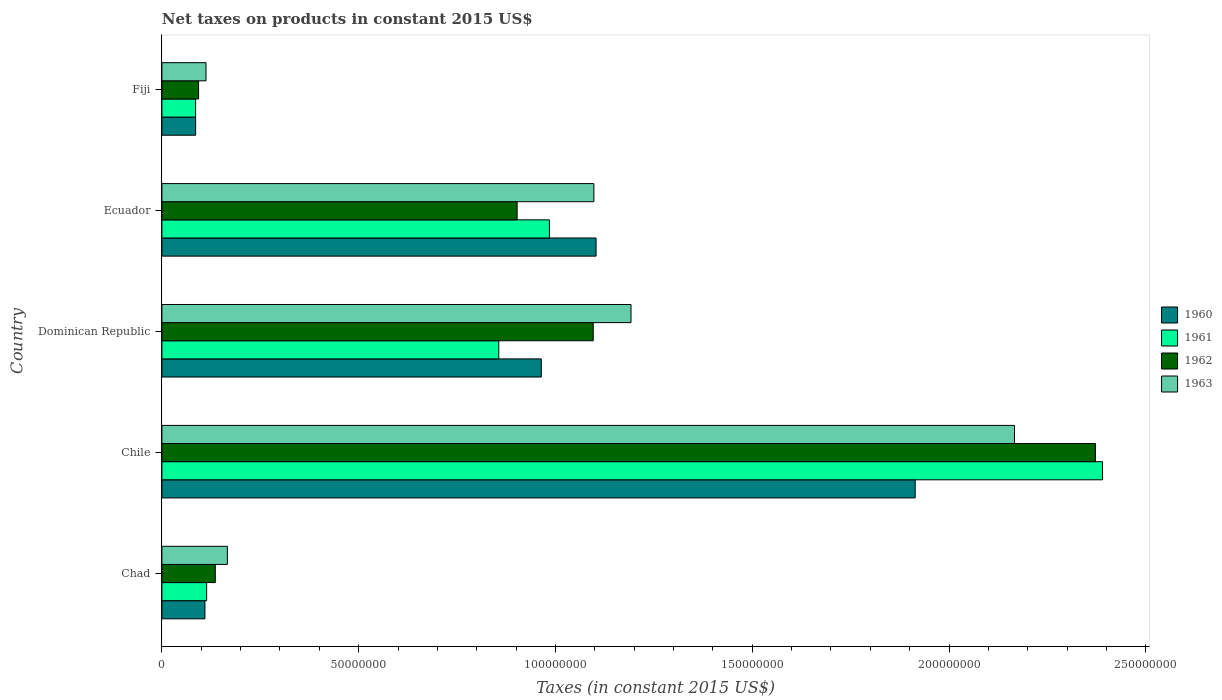Are the number of bars per tick equal to the number of legend labels?
Offer a terse response. Yes. Are the number of bars on each tick of the Y-axis equal?
Offer a very short reply. Yes. What is the label of the 2nd group of bars from the top?
Offer a very short reply. Ecuador. What is the net taxes on products in 1962 in Dominican Republic?
Make the answer very short. 1.10e+08. Across all countries, what is the maximum net taxes on products in 1963?
Offer a very short reply. 2.17e+08. Across all countries, what is the minimum net taxes on products in 1962?
Your answer should be very brief. 9.32e+06. In which country was the net taxes on products in 1960 minimum?
Ensure brevity in your answer.  Fiji. What is the total net taxes on products in 1962 in the graph?
Provide a succinct answer. 4.60e+08. What is the difference between the net taxes on products in 1962 in Chile and that in Fiji?
Make the answer very short. 2.28e+08. What is the difference between the net taxes on products in 1963 in Chile and the net taxes on products in 1960 in Fiji?
Provide a short and direct response. 2.08e+08. What is the average net taxes on products in 1960 per country?
Ensure brevity in your answer.  8.35e+07. What is the difference between the net taxes on products in 1962 and net taxes on products in 1960 in Chad?
Offer a very short reply. 2.63e+06. In how many countries, is the net taxes on products in 1963 greater than 150000000 US$?
Make the answer very short. 1. What is the ratio of the net taxes on products in 1960 in Chad to that in Chile?
Offer a terse response. 0.06. Is the net taxes on products in 1961 in Chile less than that in Fiji?
Provide a short and direct response. No. Is the difference between the net taxes on products in 1962 in Chad and Chile greater than the difference between the net taxes on products in 1960 in Chad and Chile?
Keep it short and to the point. No. What is the difference between the highest and the second highest net taxes on products in 1962?
Your response must be concise. 1.28e+08. What is the difference between the highest and the lowest net taxes on products in 1961?
Your answer should be compact. 2.30e+08. In how many countries, is the net taxes on products in 1961 greater than the average net taxes on products in 1961 taken over all countries?
Your answer should be compact. 2. What does the 4th bar from the top in Fiji represents?
Ensure brevity in your answer.  1960. What does the 4th bar from the bottom in Dominican Republic represents?
Your answer should be compact. 1963. Is it the case that in every country, the sum of the net taxes on products in 1962 and net taxes on products in 1963 is greater than the net taxes on products in 1961?
Give a very brief answer. Yes. How many bars are there?
Your answer should be very brief. 20. How many countries are there in the graph?
Your answer should be compact. 5. What is the difference between two consecutive major ticks on the X-axis?
Provide a succinct answer. 5.00e+07. Are the values on the major ticks of X-axis written in scientific E-notation?
Make the answer very short. No. Does the graph contain any zero values?
Provide a short and direct response. No. Where does the legend appear in the graph?
Give a very brief answer. Center right. How many legend labels are there?
Your response must be concise. 4. What is the title of the graph?
Keep it short and to the point. Net taxes on products in constant 2015 US$. What is the label or title of the X-axis?
Make the answer very short. Taxes (in constant 2015 US$). What is the label or title of the Y-axis?
Ensure brevity in your answer.  Country. What is the Taxes (in constant 2015 US$) in 1960 in Chad?
Provide a short and direct response. 1.09e+07. What is the Taxes (in constant 2015 US$) of 1961 in Chad?
Offer a terse response. 1.14e+07. What is the Taxes (in constant 2015 US$) of 1962 in Chad?
Make the answer very short. 1.36e+07. What is the Taxes (in constant 2015 US$) in 1963 in Chad?
Your answer should be very brief. 1.66e+07. What is the Taxes (in constant 2015 US$) in 1960 in Chile?
Your response must be concise. 1.91e+08. What is the Taxes (in constant 2015 US$) in 1961 in Chile?
Offer a very short reply. 2.39e+08. What is the Taxes (in constant 2015 US$) in 1962 in Chile?
Provide a short and direct response. 2.37e+08. What is the Taxes (in constant 2015 US$) in 1963 in Chile?
Give a very brief answer. 2.17e+08. What is the Taxes (in constant 2015 US$) in 1960 in Dominican Republic?
Give a very brief answer. 9.64e+07. What is the Taxes (in constant 2015 US$) in 1961 in Dominican Republic?
Your answer should be compact. 8.56e+07. What is the Taxes (in constant 2015 US$) of 1962 in Dominican Republic?
Ensure brevity in your answer.  1.10e+08. What is the Taxes (in constant 2015 US$) in 1963 in Dominican Republic?
Give a very brief answer. 1.19e+08. What is the Taxes (in constant 2015 US$) in 1960 in Ecuador?
Offer a terse response. 1.10e+08. What is the Taxes (in constant 2015 US$) in 1961 in Ecuador?
Make the answer very short. 9.85e+07. What is the Taxes (in constant 2015 US$) in 1962 in Ecuador?
Your answer should be compact. 9.03e+07. What is the Taxes (in constant 2015 US$) in 1963 in Ecuador?
Offer a very short reply. 1.10e+08. What is the Taxes (in constant 2015 US$) in 1960 in Fiji?
Keep it short and to the point. 8.56e+06. What is the Taxes (in constant 2015 US$) in 1961 in Fiji?
Your answer should be very brief. 8.56e+06. What is the Taxes (in constant 2015 US$) in 1962 in Fiji?
Keep it short and to the point. 9.32e+06. What is the Taxes (in constant 2015 US$) of 1963 in Fiji?
Your answer should be very brief. 1.12e+07. Across all countries, what is the maximum Taxes (in constant 2015 US$) of 1960?
Ensure brevity in your answer.  1.91e+08. Across all countries, what is the maximum Taxes (in constant 2015 US$) in 1961?
Offer a very short reply. 2.39e+08. Across all countries, what is the maximum Taxes (in constant 2015 US$) in 1962?
Make the answer very short. 2.37e+08. Across all countries, what is the maximum Taxes (in constant 2015 US$) in 1963?
Ensure brevity in your answer.  2.17e+08. Across all countries, what is the minimum Taxes (in constant 2015 US$) of 1960?
Your response must be concise. 8.56e+06. Across all countries, what is the minimum Taxes (in constant 2015 US$) of 1961?
Your answer should be compact. 8.56e+06. Across all countries, what is the minimum Taxes (in constant 2015 US$) of 1962?
Your answer should be very brief. 9.32e+06. Across all countries, what is the minimum Taxes (in constant 2015 US$) of 1963?
Offer a terse response. 1.12e+07. What is the total Taxes (in constant 2015 US$) in 1960 in the graph?
Offer a terse response. 4.18e+08. What is the total Taxes (in constant 2015 US$) of 1961 in the graph?
Give a very brief answer. 4.43e+08. What is the total Taxes (in constant 2015 US$) of 1962 in the graph?
Your response must be concise. 4.60e+08. What is the total Taxes (in constant 2015 US$) of 1963 in the graph?
Give a very brief answer. 4.73e+08. What is the difference between the Taxes (in constant 2015 US$) in 1960 in Chad and that in Chile?
Provide a succinct answer. -1.80e+08. What is the difference between the Taxes (in constant 2015 US$) in 1961 in Chad and that in Chile?
Provide a short and direct response. -2.28e+08. What is the difference between the Taxes (in constant 2015 US$) of 1962 in Chad and that in Chile?
Your response must be concise. -2.24e+08. What is the difference between the Taxes (in constant 2015 US$) in 1963 in Chad and that in Chile?
Provide a short and direct response. -2.00e+08. What is the difference between the Taxes (in constant 2015 US$) in 1960 in Chad and that in Dominican Republic?
Your answer should be very brief. -8.55e+07. What is the difference between the Taxes (in constant 2015 US$) of 1961 in Chad and that in Dominican Republic?
Offer a terse response. -7.42e+07. What is the difference between the Taxes (in constant 2015 US$) of 1962 in Chad and that in Dominican Republic?
Ensure brevity in your answer.  -9.60e+07. What is the difference between the Taxes (in constant 2015 US$) in 1963 in Chad and that in Dominican Republic?
Give a very brief answer. -1.03e+08. What is the difference between the Taxes (in constant 2015 US$) in 1960 in Chad and that in Ecuador?
Your answer should be compact. -9.94e+07. What is the difference between the Taxes (in constant 2015 US$) of 1961 in Chad and that in Ecuador?
Your answer should be compact. -8.71e+07. What is the difference between the Taxes (in constant 2015 US$) in 1962 in Chad and that in Ecuador?
Ensure brevity in your answer.  -7.67e+07. What is the difference between the Taxes (in constant 2015 US$) of 1963 in Chad and that in Ecuador?
Your answer should be very brief. -9.31e+07. What is the difference between the Taxes (in constant 2015 US$) of 1960 in Chad and that in Fiji?
Offer a very short reply. 2.37e+06. What is the difference between the Taxes (in constant 2015 US$) of 1961 in Chad and that in Fiji?
Your answer should be very brief. 2.81e+06. What is the difference between the Taxes (in constant 2015 US$) in 1962 in Chad and that in Fiji?
Make the answer very short. 4.25e+06. What is the difference between the Taxes (in constant 2015 US$) in 1963 in Chad and that in Fiji?
Provide a short and direct response. 5.43e+06. What is the difference between the Taxes (in constant 2015 US$) in 1960 in Chile and that in Dominican Republic?
Make the answer very short. 9.50e+07. What is the difference between the Taxes (in constant 2015 US$) in 1961 in Chile and that in Dominican Republic?
Provide a short and direct response. 1.53e+08. What is the difference between the Taxes (in constant 2015 US$) of 1962 in Chile and that in Dominican Republic?
Your answer should be compact. 1.28e+08. What is the difference between the Taxes (in constant 2015 US$) of 1963 in Chile and that in Dominican Republic?
Make the answer very short. 9.74e+07. What is the difference between the Taxes (in constant 2015 US$) in 1960 in Chile and that in Ecuador?
Your response must be concise. 8.11e+07. What is the difference between the Taxes (in constant 2015 US$) of 1961 in Chile and that in Ecuador?
Offer a very short reply. 1.41e+08. What is the difference between the Taxes (in constant 2015 US$) of 1962 in Chile and that in Ecuador?
Keep it short and to the point. 1.47e+08. What is the difference between the Taxes (in constant 2015 US$) in 1963 in Chile and that in Ecuador?
Your answer should be very brief. 1.07e+08. What is the difference between the Taxes (in constant 2015 US$) in 1960 in Chile and that in Fiji?
Your response must be concise. 1.83e+08. What is the difference between the Taxes (in constant 2015 US$) of 1961 in Chile and that in Fiji?
Give a very brief answer. 2.30e+08. What is the difference between the Taxes (in constant 2015 US$) in 1962 in Chile and that in Fiji?
Make the answer very short. 2.28e+08. What is the difference between the Taxes (in constant 2015 US$) of 1963 in Chile and that in Fiji?
Ensure brevity in your answer.  2.05e+08. What is the difference between the Taxes (in constant 2015 US$) in 1960 in Dominican Republic and that in Ecuador?
Provide a succinct answer. -1.39e+07. What is the difference between the Taxes (in constant 2015 US$) of 1961 in Dominican Republic and that in Ecuador?
Your response must be concise. -1.29e+07. What is the difference between the Taxes (in constant 2015 US$) of 1962 in Dominican Republic and that in Ecuador?
Offer a very short reply. 1.93e+07. What is the difference between the Taxes (in constant 2015 US$) of 1963 in Dominican Republic and that in Ecuador?
Keep it short and to the point. 9.44e+06. What is the difference between the Taxes (in constant 2015 US$) of 1960 in Dominican Republic and that in Fiji?
Ensure brevity in your answer.  8.78e+07. What is the difference between the Taxes (in constant 2015 US$) in 1961 in Dominican Republic and that in Fiji?
Your answer should be compact. 7.70e+07. What is the difference between the Taxes (in constant 2015 US$) in 1962 in Dominican Republic and that in Fiji?
Your answer should be compact. 1.00e+08. What is the difference between the Taxes (in constant 2015 US$) in 1963 in Dominican Republic and that in Fiji?
Your response must be concise. 1.08e+08. What is the difference between the Taxes (in constant 2015 US$) of 1960 in Ecuador and that in Fiji?
Offer a very short reply. 1.02e+08. What is the difference between the Taxes (in constant 2015 US$) in 1961 in Ecuador and that in Fiji?
Provide a short and direct response. 8.99e+07. What is the difference between the Taxes (in constant 2015 US$) in 1962 in Ecuador and that in Fiji?
Give a very brief answer. 8.09e+07. What is the difference between the Taxes (in constant 2015 US$) in 1963 in Ecuador and that in Fiji?
Provide a short and direct response. 9.86e+07. What is the difference between the Taxes (in constant 2015 US$) of 1960 in Chad and the Taxes (in constant 2015 US$) of 1961 in Chile?
Keep it short and to the point. -2.28e+08. What is the difference between the Taxes (in constant 2015 US$) of 1960 in Chad and the Taxes (in constant 2015 US$) of 1962 in Chile?
Provide a succinct answer. -2.26e+08. What is the difference between the Taxes (in constant 2015 US$) of 1960 in Chad and the Taxes (in constant 2015 US$) of 1963 in Chile?
Your answer should be very brief. -2.06e+08. What is the difference between the Taxes (in constant 2015 US$) of 1961 in Chad and the Taxes (in constant 2015 US$) of 1962 in Chile?
Keep it short and to the point. -2.26e+08. What is the difference between the Taxes (in constant 2015 US$) in 1961 in Chad and the Taxes (in constant 2015 US$) in 1963 in Chile?
Provide a succinct answer. -2.05e+08. What is the difference between the Taxes (in constant 2015 US$) of 1962 in Chad and the Taxes (in constant 2015 US$) of 1963 in Chile?
Provide a succinct answer. -2.03e+08. What is the difference between the Taxes (in constant 2015 US$) of 1960 in Chad and the Taxes (in constant 2015 US$) of 1961 in Dominican Republic?
Ensure brevity in your answer.  -7.47e+07. What is the difference between the Taxes (in constant 2015 US$) of 1960 in Chad and the Taxes (in constant 2015 US$) of 1962 in Dominican Republic?
Offer a terse response. -9.87e+07. What is the difference between the Taxes (in constant 2015 US$) of 1960 in Chad and the Taxes (in constant 2015 US$) of 1963 in Dominican Republic?
Make the answer very short. -1.08e+08. What is the difference between the Taxes (in constant 2015 US$) in 1961 in Chad and the Taxes (in constant 2015 US$) in 1962 in Dominican Republic?
Your answer should be compact. -9.82e+07. What is the difference between the Taxes (in constant 2015 US$) in 1961 in Chad and the Taxes (in constant 2015 US$) in 1963 in Dominican Republic?
Your answer should be compact. -1.08e+08. What is the difference between the Taxes (in constant 2015 US$) in 1962 in Chad and the Taxes (in constant 2015 US$) in 1963 in Dominican Republic?
Offer a terse response. -1.06e+08. What is the difference between the Taxes (in constant 2015 US$) in 1960 in Chad and the Taxes (in constant 2015 US$) in 1961 in Ecuador?
Provide a succinct answer. -8.75e+07. What is the difference between the Taxes (in constant 2015 US$) in 1960 in Chad and the Taxes (in constant 2015 US$) in 1962 in Ecuador?
Ensure brevity in your answer.  -7.93e+07. What is the difference between the Taxes (in constant 2015 US$) in 1960 in Chad and the Taxes (in constant 2015 US$) in 1963 in Ecuador?
Make the answer very short. -9.88e+07. What is the difference between the Taxes (in constant 2015 US$) in 1961 in Chad and the Taxes (in constant 2015 US$) in 1962 in Ecuador?
Offer a very short reply. -7.89e+07. What is the difference between the Taxes (in constant 2015 US$) in 1961 in Chad and the Taxes (in constant 2015 US$) in 1963 in Ecuador?
Offer a terse response. -9.84e+07. What is the difference between the Taxes (in constant 2015 US$) of 1962 in Chad and the Taxes (in constant 2015 US$) of 1963 in Ecuador?
Provide a short and direct response. -9.62e+07. What is the difference between the Taxes (in constant 2015 US$) in 1960 in Chad and the Taxes (in constant 2015 US$) in 1961 in Fiji?
Offer a very short reply. 2.37e+06. What is the difference between the Taxes (in constant 2015 US$) in 1960 in Chad and the Taxes (in constant 2015 US$) in 1962 in Fiji?
Keep it short and to the point. 1.62e+06. What is the difference between the Taxes (in constant 2015 US$) in 1960 in Chad and the Taxes (in constant 2015 US$) in 1963 in Fiji?
Offer a terse response. -2.73e+05. What is the difference between the Taxes (in constant 2015 US$) in 1961 in Chad and the Taxes (in constant 2015 US$) in 1962 in Fiji?
Your answer should be compact. 2.05e+06. What is the difference between the Taxes (in constant 2015 US$) of 1961 in Chad and the Taxes (in constant 2015 US$) of 1963 in Fiji?
Make the answer very short. 1.61e+05. What is the difference between the Taxes (in constant 2015 US$) in 1962 in Chad and the Taxes (in constant 2015 US$) in 1963 in Fiji?
Your answer should be compact. 2.36e+06. What is the difference between the Taxes (in constant 2015 US$) in 1960 in Chile and the Taxes (in constant 2015 US$) in 1961 in Dominican Republic?
Your response must be concise. 1.06e+08. What is the difference between the Taxes (in constant 2015 US$) of 1960 in Chile and the Taxes (in constant 2015 US$) of 1962 in Dominican Republic?
Keep it short and to the point. 8.18e+07. What is the difference between the Taxes (in constant 2015 US$) of 1960 in Chile and the Taxes (in constant 2015 US$) of 1963 in Dominican Republic?
Provide a succinct answer. 7.22e+07. What is the difference between the Taxes (in constant 2015 US$) of 1961 in Chile and the Taxes (in constant 2015 US$) of 1962 in Dominican Republic?
Your answer should be very brief. 1.29e+08. What is the difference between the Taxes (in constant 2015 US$) in 1961 in Chile and the Taxes (in constant 2015 US$) in 1963 in Dominican Republic?
Your answer should be compact. 1.20e+08. What is the difference between the Taxes (in constant 2015 US$) of 1962 in Chile and the Taxes (in constant 2015 US$) of 1963 in Dominican Republic?
Provide a short and direct response. 1.18e+08. What is the difference between the Taxes (in constant 2015 US$) of 1960 in Chile and the Taxes (in constant 2015 US$) of 1961 in Ecuador?
Make the answer very short. 9.29e+07. What is the difference between the Taxes (in constant 2015 US$) of 1960 in Chile and the Taxes (in constant 2015 US$) of 1962 in Ecuador?
Your answer should be compact. 1.01e+08. What is the difference between the Taxes (in constant 2015 US$) in 1960 in Chile and the Taxes (in constant 2015 US$) in 1963 in Ecuador?
Offer a terse response. 8.16e+07. What is the difference between the Taxes (in constant 2015 US$) in 1961 in Chile and the Taxes (in constant 2015 US$) in 1962 in Ecuador?
Keep it short and to the point. 1.49e+08. What is the difference between the Taxes (in constant 2015 US$) of 1961 in Chile and the Taxes (in constant 2015 US$) of 1963 in Ecuador?
Provide a short and direct response. 1.29e+08. What is the difference between the Taxes (in constant 2015 US$) in 1962 in Chile and the Taxes (in constant 2015 US$) in 1963 in Ecuador?
Provide a succinct answer. 1.27e+08. What is the difference between the Taxes (in constant 2015 US$) of 1960 in Chile and the Taxes (in constant 2015 US$) of 1961 in Fiji?
Give a very brief answer. 1.83e+08. What is the difference between the Taxes (in constant 2015 US$) in 1960 in Chile and the Taxes (in constant 2015 US$) in 1962 in Fiji?
Your answer should be very brief. 1.82e+08. What is the difference between the Taxes (in constant 2015 US$) in 1960 in Chile and the Taxes (in constant 2015 US$) in 1963 in Fiji?
Keep it short and to the point. 1.80e+08. What is the difference between the Taxes (in constant 2015 US$) of 1961 in Chile and the Taxes (in constant 2015 US$) of 1962 in Fiji?
Your answer should be compact. 2.30e+08. What is the difference between the Taxes (in constant 2015 US$) of 1961 in Chile and the Taxes (in constant 2015 US$) of 1963 in Fiji?
Offer a terse response. 2.28e+08. What is the difference between the Taxes (in constant 2015 US$) in 1962 in Chile and the Taxes (in constant 2015 US$) in 1963 in Fiji?
Provide a short and direct response. 2.26e+08. What is the difference between the Taxes (in constant 2015 US$) of 1960 in Dominican Republic and the Taxes (in constant 2015 US$) of 1961 in Ecuador?
Provide a succinct answer. -2.07e+06. What is the difference between the Taxes (in constant 2015 US$) of 1960 in Dominican Republic and the Taxes (in constant 2015 US$) of 1962 in Ecuador?
Make the answer very short. 6.14e+06. What is the difference between the Taxes (in constant 2015 US$) in 1960 in Dominican Republic and the Taxes (in constant 2015 US$) in 1963 in Ecuador?
Give a very brief answer. -1.34e+07. What is the difference between the Taxes (in constant 2015 US$) in 1961 in Dominican Republic and the Taxes (in constant 2015 US$) in 1962 in Ecuador?
Offer a terse response. -4.66e+06. What is the difference between the Taxes (in constant 2015 US$) in 1961 in Dominican Republic and the Taxes (in constant 2015 US$) in 1963 in Ecuador?
Ensure brevity in your answer.  -2.42e+07. What is the difference between the Taxes (in constant 2015 US$) in 1962 in Dominican Republic and the Taxes (in constant 2015 US$) in 1963 in Ecuador?
Your response must be concise. -1.64e+05. What is the difference between the Taxes (in constant 2015 US$) of 1960 in Dominican Republic and the Taxes (in constant 2015 US$) of 1961 in Fiji?
Give a very brief answer. 8.78e+07. What is the difference between the Taxes (in constant 2015 US$) of 1960 in Dominican Republic and the Taxes (in constant 2015 US$) of 1962 in Fiji?
Offer a terse response. 8.71e+07. What is the difference between the Taxes (in constant 2015 US$) of 1960 in Dominican Republic and the Taxes (in constant 2015 US$) of 1963 in Fiji?
Offer a very short reply. 8.52e+07. What is the difference between the Taxes (in constant 2015 US$) of 1961 in Dominican Republic and the Taxes (in constant 2015 US$) of 1962 in Fiji?
Give a very brief answer. 7.63e+07. What is the difference between the Taxes (in constant 2015 US$) of 1961 in Dominican Republic and the Taxes (in constant 2015 US$) of 1963 in Fiji?
Give a very brief answer. 7.44e+07. What is the difference between the Taxes (in constant 2015 US$) in 1962 in Dominican Republic and the Taxes (in constant 2015 US$) in 1963 in Fiji?
Your answer should be compact. 9.84e+07. What is the difference between the Taxes (in constant 2015 US$) in 1960 in Ecuador and the Taxes (in constant 2015 US$) in 1961 in Fiji?
Provide a short and direct response. 1.02e+08. What is the difference between the Taxes (in constant 2015 US$) of 1960 in Ecuador and the Taxes (in constant 2015 US$) of 1962 in Fiji?
Offer a very short reply. 1.01e+08. What is the difference between the Taxes (in constant 2015 US$) in 1960 in Ecuador and the Taxes (in constant 2015 US$) in 1963 in Fiji?
Your answer should be very brief. 9.91e+07. What is the difference between the Taxes (in constant 2015 US$) of 1961 in Ecuador and the Taxes (in constant 2015 US$) of 1962 in Fiji?
Provide a short and direct response. 8.91e+07. What is the difference between the Taxes (in constant 2015 US$) in 1961 in Ecuador and the Taxes (in constant 2015 US$) in 1963 in Fiji?
Offer a terse response. 8.73e+07. What is the difference between the Taxes (in constant 2015 US$) of 1962 in Ecuador and the Taxes (in constant 2015 US$) of 1963 in Fiji?
Give a very brief answer. 7.91e+07. What is the average Taxes (in constant 2015 US$) in 1960 per country?
Your answer should be very brief. 8.35e+07. What is the average Taxes (in constant 2015 US$) of 1961 per country?
Offer a very short reply. 8.86e+07. What is the average Taxes (in constant 2015 US$) in 1962 per country?
Your answer should be very brief. 9.20e+07. What is the average Taxes (in constant 2015 US$) of 1963 per country?
Your answer should be compact. 9.47e+07. What is the difference between the Taxes (in constant 2015 US$) in 1960 and Taxes (in constant 2015 US$) in 1961 in Chad?
Your answer should be compact. -4.34e+05. What is the difference between the Taxes (in constant 2015 US$) of 1960 and Taxes (in constant 2015 US$) of 1962 in Chad?
Offer a very short reply. -2.63e+06. What is the difference between the Taxes (in constant 2015 US$) in 1960 and Taxes (in constant 2015 US$) in 1963 in Chad?
Your answer should be compact. -5.70e+06. What is the difference between the Taxes (in constant 2015 US$) of 1961 and Taxes (in constant 2015 US$) of 1962 in Chad?
Ensure brevity in your answer.  -2.20e+06. What is the difference between the Taxes (in constant 2015 US$) of 1961 and Taxes (in constant 2015 US$) of 1963 in Chad?
Keep it short and to the point. -5.26e+06. What is the difference between the Taxes (in constant 2015 US$) in 1962 and Taxes (in constant 2015 US$) in 1963 in Chad?
Ensure brevity in your answer.  -3.06e+06. What is the difference between the Taxes (in constant 2015 US$) in 1960 and Taxes (in constant 2015 US$) in 1961 in Chile?
Keep it short and to the point. -4.76e+07. What is the difference between the Taxes (in constant 2015 US$) in 1960 and Taxes (in constant 2015 US$) in 1962 in Chile?
Make the answer very short. -4.58e+07. What is the difference between the Taxes (in constant 2015 US$) of 1960 and Taxes (in constant 2015 US$) of 1963 in Chile?
Ensure brevity in your answer.  -2.52e+07. What is the difference between the Taxes (in constant 2015 US$) of 1961 and Taxes (in constant 2015 US$) of 1962 in Chile?
Make the answer very short. 1.81e+06. What is the difference between the Taxes (in constant 2015 US$) in 1961 and Taxes (in constant 2015 US$) in 1963 in Chile?
Your response must be concise. 2.24e+07. What is the difference between the Taxes (in constant 2015 US$) of 1962 and Taxes (in constant 2015 US$) of 1963 in Chile?
Your answer should be compact. 2.06e+07. What is the difference between the Taxes (in constant 2015 US$) in 1960 and Taxes (in constant 2015 US$) in 1961 in Dominican Republic?
Your answer should be very brief. 1.08e+07. What is the difference between the Taxes (in constant 2015 US$) of 1960 and Taxes (in constant 2015 US$) of 1962 in Dominican Republic?
Provide a succinct answer. -1.32e+07. What is the difference between the Taxes (in constant 2015 US$) of 1960 and Taxes (in constant 2015 US$) of 1963 in Dominican Republic?
Provide a short and direct response. -2.28e+07. What is the difference between the Taxes (in constant 2015 US$) of 1961 and Taxes (in constant 2015 US$) of 1962 in Dominican Republic?
Your answer should be compact. -2.40e+07. What is the difference between the Taxes (in constant 2015 US$) of 1961 and Taxes (in constant 2015 US$) of 1963 in Dominican Republic?
Provide a succinct answer. -3.36e+07. What is the difference between the Taxes (in constant 2015 US$) in 1962 and Taxes (in constant 2015 US$) in 1963 in Dominican Republic?
Offer a very short reply. -9.60e+06. What is the difference between the Taxes (in constant 2015 US$) in 1960 and Taxes (in constant 2015 US$) in 1961 in Ecuador?
Offer a terse response. 1.19e+07. What is the difference between the Taxes (in constant 2015 US$) of 1960 and Taxes (in constant 2015 US$) of 1962 in Ecuador?
Offer a terse response. 2.01e+07. What is the difference between the Taxes (in constant 2015 US$) in 1960 and Taxes (in constant 2015 US$) in 1963 in Ecuador?
Give a very brief answer. 5.57e+05. What is the difference between the Taxes (in constant 2015 US$) of 1961 and Taxes (in constant 2015 US$) of 1962 in Ecuador?
Your answer should be very brief. 8.21e+06. What is the difference between the Taxes (in constant 2015 US$) of 1961 and Taxes (in constant 2015 US$) of 1963 in Ecuador?
Give a very brief answer. -1.13e+07. What is the difference between the Taxes (in constant 2015 US$) in 1962 and Taxes (in constant 2015 US$) in 1963 in Ecuador?
Make the answer very short. -1.95e+07. What is the difference between the Taxes (in constant 2015 US$) of 1960 and Taxes (in constant 2015 US$) of 1961 in Fiji?
Your response must be concise. 0. What is the difference between the Taxes (in constant 2015 US$) in 1960 and Taxes (in constant 2015 US$) in 1962 in Fiji?
Offer a terse response. -7.56e+05. What is the difference between the Taxes (in constant 2015 US$) in 1960 and Taxes (in constant 2015 US$) in 1963 in Fiji?
Offer a very short reply. -2.64e+06. What is the difference between the Taxes (in constant 2015 US$) in 1961 and Taxes (in constant 2015 US$) in 1962 in Fiji?
Ensure brevity in your answer.  -7.56e+05. What is the difference between the Taxes (in constant 2015 US$) of 1961 and Taxes (in constant 2015 US$) of 1963 in Fiji?
Ensure brevity in your answer.  -2.64e+06. What is the difference between the Taxes (in constant 2015 US$) in 1962 and Taxes (in constant 2015 US$) in 1963 in Fiji?
Make the answer very short. -1.89e+06. What is the ratio of the Taxes (in constant 2015 US$) in 1960 in Chad to that in Chile?
Provide a succinct answer. 0.06. What is the ratio of the Taxes (in constant 2015 US$) in 1961 in Chad to that in Chile?
Keep it short and to the point. 0.05. What is the ratio of the Taxes (in constant 2015 US$) in 1962 in Chad to that in Chile?
Give a very brief answer. 0.06. What is the ratio of the Taxes (in constant 2015 US$) of 1963 in Chad to that in Chile?
Keep it short and to the point. 0.08. What is the ratio of the Taxes (in constant 2015 US$) in 1960 in Chad to that in Dominican Republic?
Keep it short and to the point. 0.11. What is the ratio of the Taxes (in constant 2015 US$) in 1961 in Chad to that in Dominican Republic?
Ensure brevity in your answer.  0.13. What is the ratio of the Taxes (in constant 2015 US$) of 1962 in Chad to that in Dominican Republic?
Ensure brevity in your answer.  0.12. What is the ratio of the Taxes (in constant 2015 US$) in 1963 in Chad to that in Dominican Republic?
Make the answer very short. 0.14. What is the ratio of the Taxes (in constant 2015 US$) of 1960 in Chad to that in Ecuador?
Provide a succinct answer. 0.1. What is the ratio of the Taxes (in constant 2015 US$) of 1961 in Chad to that in Ecuador?
Provide a short and direct response. 0.12. What is the ratio of the Taxes (in constant 2015 US$) in 1962 in Chad to that in Ecuador?
Provide a succinct answer. 0.15. What is the ratio of the Taxes (in constant 2015 US$) of 1963 in Chad to that in Ecuador?
Give a very brief answer. 0.15. What is the ratio of the Taxes (in constant 2015 US$) in 1960 in Chad to that in Fiji?
Make the answer very short. 1.28. What is the ratio of the Taxes (in constant 2015 US$) in 1961 in Chad to that in Fiji?
Give a very brief answer. 1.33. What is the ratio of the Taxes (in constant 2015 US$) in 1962 in Chad to that in Fiji?
Give a very brief answer. 1.46. What is the ratio of the Taxes (in constant 2015 US$) in 1963 in Chad to that in Fiji?
Keep it short and to the point. 1.48. What is the ratio of the Taxes (in constant 2015 US$) in 1960 in Chile to that in Dominican Republic?
Your response must be concise. 1.99. What is the ratio of the Taxes (in constant 2015 US$) of 1961 in Chile to that in Dominican Republic?
Your answer should be compact. 2.79. What is the ratio of the Taxes (in constant 2015 US$) of 1962 in Chile to that in Dominican Republic?
Offer a terse response. 2.16. What is the ratio of the Taxes (in constant 2015 US$) of 1963 in Chile to that in Dominican Republic?
Ensure brevity in your answer.  1.82. What is the ratio of the Taxes (in constant 2015 US$) in 1960 in Chile to that in Ecuador?
Ensure brevity in your answer.  1.74. What is the ratio of the Taxes (in constant 2015 US$) in 1961 in Chile to that in Ecuador?
Offer a terse response. 2.43. What is the ratio of the Taxes (in constant 2015 US$) of 1962 in Chile to that in Ecuador?
Offer a terse response. 2.63. What is the ratio of the Taxes (in constant 2015 US$) in 1963 in Chile to that in Ecuador?
Provide a succinct answer. 1.97. What is the ratio of the Taxes (in constant 2015 US$) of 1960 in Chile to that in Fiji?
Ensure brevity in your answer.  22.35. What is the ratio of the Taxes (in constant 2015 US$) in 1961 in Chile to that in Fiji?
Your response must be concise. 27.91. What is the ratio of the Taxes (in constant 2015 US$) of 1962 in Chile to that in Fiji?
Provide a short and direct response. 25.45. What is the ratio of the Taxes (in constant 2015 US$) in 1963 in Chile to that in Fiji?
Provide a succinct answer. 19.33. What is the ratio of the Taxes (in constant 2015 US$) in 1960 in Dominican Republic to that in Ecuador?
Keep it short and to the point. 0.87. What is the ratio of the Taxes (in constant 2015 US$) in 1961 in Dominican Republic to that in Ecuador?
Ensure brevity in your answer.  0.87. What is the ratio of the Taxes (in constant 2015 US$) in 1962 in Dominican Republic to that in Ecuador?
Provide a succinct answer. 1.21. What is the ratio of the Taxes (in constant 2015 US$) of 1963 in Dominican Republic to that in Ecuador?
Keep it short and to the point. 1.09. What is the ratio of the Taxes (in constant 2015 US$) in 1960 in Dominican Republic to that in Fiji?
Provide a succinct answer. 11.26. What is the ratio of the Taxes (in constant 2015 US$) of 1961 in Dominican Republic to that in Fiji?
Keep it short and to the point. 10. What is the ratio of the Taxes (in constant 2015 US$) in 1962 in Dominican Republic to that in Fiji?
Your answer should be very brief. 11.76. What is the ratio of the Taxes (in constant 2015 US$) of 1963 in Dominican Republic to that in Fiji?
Your response must be concise. 10.63. What is the ratio of the Taxes (in constant 2015 US$) in 1960 in Ecuador to that in Fiji?
Make the answer very short. 12.88. What is the ratio of the Taxes (in constant 2015 US$) in 1961 in Ecuador to that in Fiji?
Offer a terse response. 11.5. What is the ratio of the Taxes (in constant 2015 US$) of 1962 in Ecuador to that in Fiji?
Ensure brevity in your answer.  9.69. What is the ratio of the Taxes (in constant 2015 US$) in 1963 in Ecuador to that in Fiji?
Offer a very short reply. 9.79. What is the difference between the highest and the second highest Taxes (in constant 2015 US$) in 1960?
Keep it short and to the point. 8.11e+07. What is the difference between the highest and the second highest Taxes (in constant 2015 US$) of 1961?
Offer a very short reply. 1.41e+08. What is the difference between the highest and the second highest Taxes (in constant 2015 US$) of 1962?
Provide a succinct answer. 1.28e+08. What is the difference between the highest and the second highest Taxes (in constant 2015 US$) in 1963?
Provide a short and direct response. 9.74e+07. What is the difference between the highest and the lowest Taxes (in constant 2015 US$) of 1960?
Keep it short and to the point. 1.83e+08. What is the difference between the highest and the lowest Taxes (in constant 2015 US$) in 1961?
Offer a terse response. 2.30e+08. What is the difference between the highest and the lowest Taxes (in constant 2015 US$) of 1962?
Your answer should be compact. 2.28e+08. What is the difference between the highest and the lowest Taxes (in constant 2015 US$) of 1963?
Your response must be concise. 2.05e+08. 